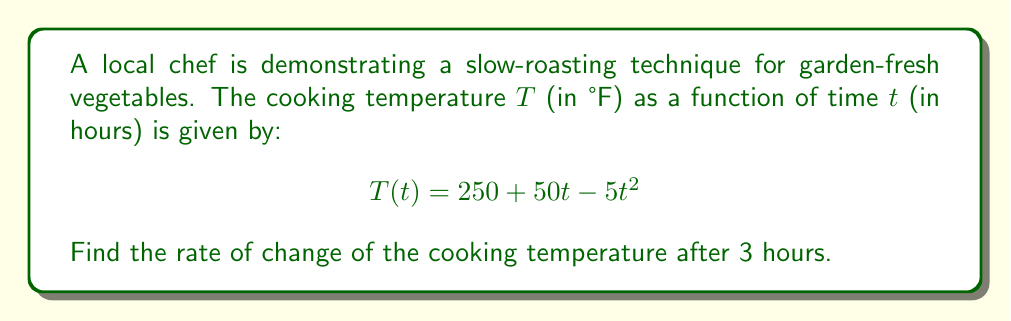Help me with this question. To find the rate of change of the cooking temperature after 3 hours, we need to calculate the derivative of the temperature function $T(t)$ and evaluate it at $t=3$.

1. First, let's find the derivative of $T(t)$:
   
   $$\frac{d}{dt}T(t) = \frac{d}{dt}(250 + 50t - 5t^2)$$
   
   Using the power rule and the constant rule of derivatives:
   
   $$T'(t) = 0 + 50 - 10t$$

2. Now we have the rate of change function $T'(t) = 50 - 10t$.

3. To find the rate of change after 3 hours, we evaluate $T'(t)$ at $t=3$:
   
   $$T'(3) = 50 - 10(3) = 50 - 30 = 20$$

4. The units for this rate of change would be °F per hour, as we're measuring the change in temperature over time.

Therefore, after 3 hours, the rate of change of the cooking temperature is 20 °F per hour.
Answer: $20$ °F/hour 